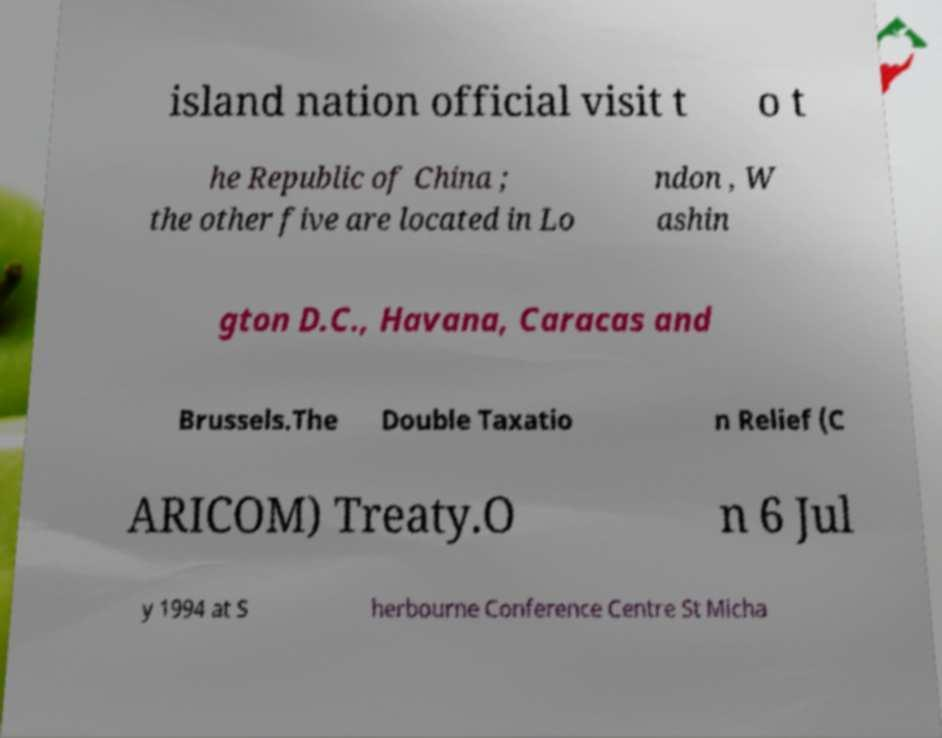Could you assist in decoding the text presented in this image and type it out clearly? island nation official visit t o t he Republic of China ; the other five are located in Lo ndon , W ashin gton D.C., Havana, Caracas and Brussels.The Double Taxatio n Relief (C ARICOM) Treaty.O n 6 Jul y 1994 at S herbourne Conference Centre St Micha 